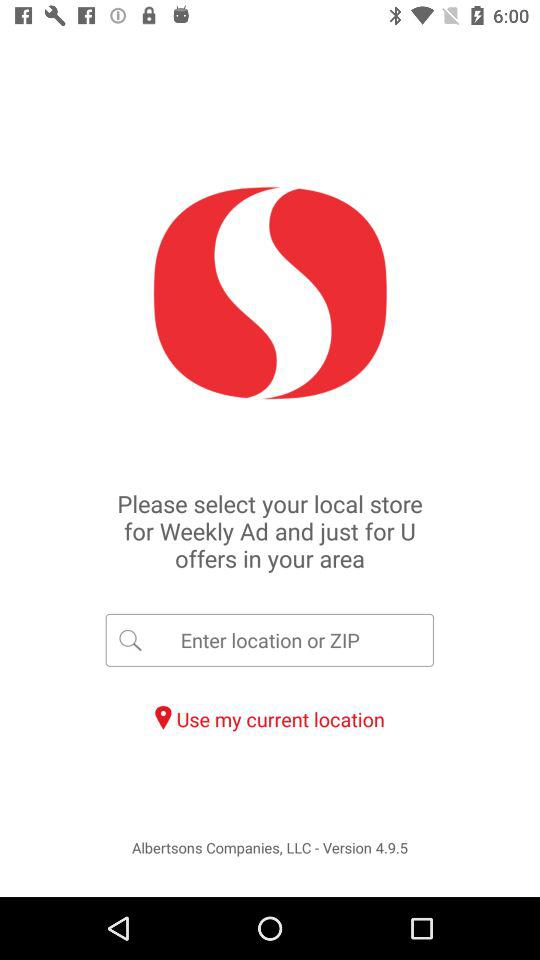What type of version is shown? The version is 4.9.5. 